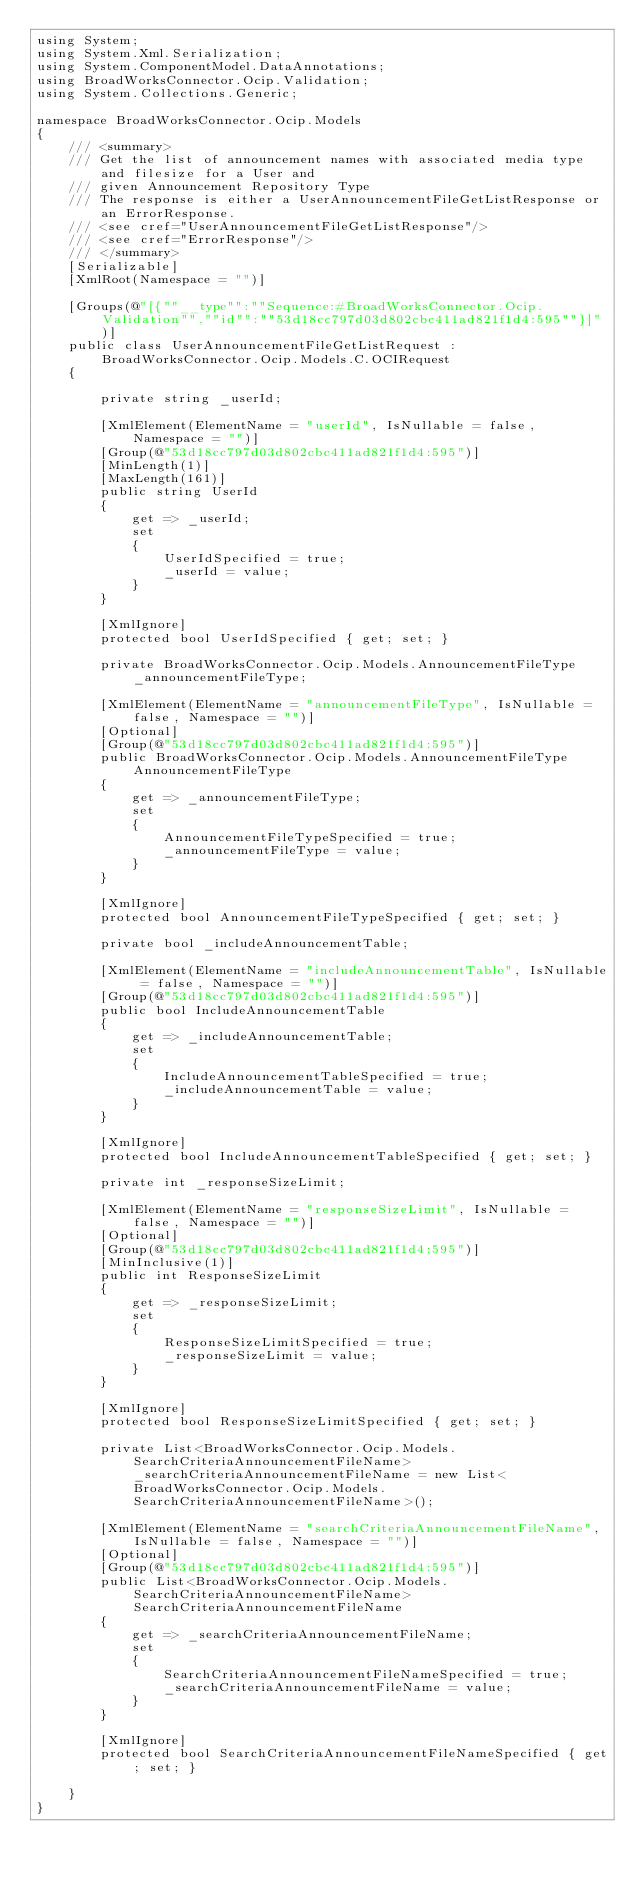<code> <loc_0><loc_0><loc_500><loc_500><_C#_>using System;
using System.Xml.Serialization;
using System.ComponentModel.DataAnnotations;
using BroadWorksConnector.Ocip.Validation;
using System.Collections.Generic;

namespace BroadWorksConnector.Ocip.Models
{
    /// <summary>
    /// Get the list of announcement names with associated media type and filesize for a User and
    /// given Announcement Repository Type
    /// The response is either a UserAnnouncementFileGetListResponse or an ErrorResponse.
    /// <see cref="UserAnnouncementFileGetListResponse"/>
    /// <see cref="ErrorResponse"/>
    /// </summary>
    [Serializable]
    [XmlRoot(Namespace = "")]

    [Groups(@"[{""__type"":""Sequence:#BroadWorksConnector.Ocip.Validation"",""id"":""53d18cc797d03d802cbc411ad821f1d4:595""}]")]
    public class UserAnnouncementFileGetListRequest : BroadWorksConnector.Ocip.Models.C.OCIRequest
    {

        private string _userId;

        [XmlElement(ElementName = "userId", IsNullable = false, Namespace = "")]
        [Group(@"53d18cc797d03d802cbc411ad821f1d4:595")]
        [MinLength(1)]
        [MaxLength(161)]
        public string UserId
        {
            get => _userId;
            set
            {
                UserIdSpecified = true;
                _userId = value;
            }
        }

        [XmlIgnore]
        protected bool UserIdSpecified { get; set; }

        private BroadWorksConnector.Ocip.Models.AnnouncementFileType _announcementFileType;

        [XmlElement(ElementName = "announcementFileType", IsNullable = false, Namespace = "")]
        [Optional]
        [Group(@"53d18cc797d03d802cbc411ad821f1d4:595")]
        public BroadWorksConnector.Ocip.Models.AnnouncementFileType AnnouncementFileType
        {
            get => _announcementFileType;
            set
            {
                AnnouncementFileTypeSpecified = true;
                _announcementFileType = value;
            }
        }

        [XmlIgnore]
        protected bool AnnouncementFileTypeSpecified { get; set; }

        private bool _includeAnnouncementTable;

        [XmlElement(ElementName = "includeAnnouncementTable", IsNullable = false, Namespace = "")]
        [Group(@"53d18cc797d03d802cbc411ad821f1d4:595")]
        public bool IncludeAnnouncementTable
        {
            get => _includeAnnouncementTable;
            set
            {
                IncludeAnnouncementTableSpecified = true;
                _includeAnnouncementTable = value;
            }
        }

        [XmlIgnore]
        protected bool IncludeAnnouncementTableSpecified { get; set; }

        private int _responseSizeLimit;

        [XmlElement(ElementName = "responseSizeLimit", IsNullable = false, Namespace = "")]
        [Optional]
        [Group(@"53d18cc797d03d802cbc411ad821f1d4:595")]
        [MinInclusive(1)]
        public int ResponseSizeLimit
        {
            get => _responseSizeLimit;
            set
            {
                ResponseSizeLimitSpecified = true;
                _responseSizeLimit = value;
            }
        }

        [XmlIgnore]
        protected bool ResponseSizeLimitSpecified { get; set; }

        private List<BroadWorksConnector.Ocip.Models.SearchCriteriaAnnouncementFileName> _searchCriteriaAnnouncementFileName = new List<BroadWorksConnector.Ocip.Models.SearchCriteriaAnnouncementFileName>();

        [XmlElement(ElementName = "searchCriteriaAnnouncementFileName", IsNullable = false, Namespace = "")]
        [Optional]
        [Group(@"53d18cc797d03d802cbc411ad821f1d4:595")]
        public List<BroadWorksConnector.Ocip.Models.SearchCriteriaAnnouncementFileName> SearchCriteriaAnnouncementFileName
        {
            get => _searchCriteriaAnnouncementFileName;
            set
            {
                SearchCriteriaAnnouncementFileNameSpecified = true;
                _searchCriteriaAnnouncementFileName = value;
            }
        }

        [XmlIgnore]
        protected bool SearchCriteriaAnnouncementFileNameSpecified { get; set; }

    }
}
</code> 